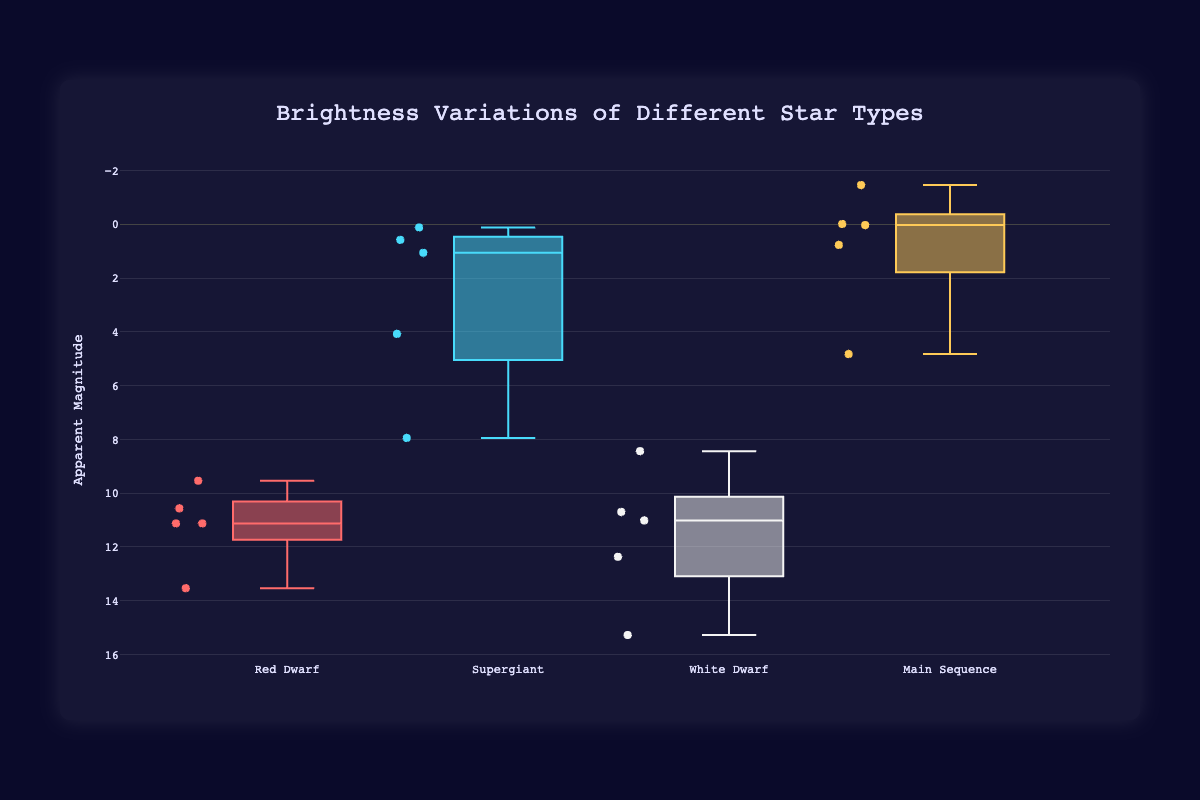What is the title of the figure? The title of the figure is mentioned at the top of the plot.
Answer: Brightness Variations of Different Star Types How many star types are shown in the figure? Count the different categories on the x-axis.
Answer: Four (Red Dwarf, Supergiant, White Dwarf, Main Sequence) Which star type has the highest median brightness? The median is represented by the line within the box. Identify the star type with the line closest to the top of the y-axis.
Answer: Main Sequence What is the approximate range of magnitudes for the White Dwarf category? Observe the top and bottom of the box plot for the White Dwarf category.
Answer: Approximately from 8.44 to 15.28 Which star in the Supergiant category has the highest magnitude? Look at the individual points on the Supergiant box plot and identify the highest value.
Answer: VY Canis Majoris Which category has a smaller interquartile range, Red Dwarf or Main Sequence? The interquartile range is the box's length. Compare the boxes of Red Dwarf and Main Sequence.
Answer: Main Sequence What is the median magnitude of the Red Dwarf category? The median is the line inside the box. Check the position of the line in the Red Dwarf box plot.
Answer: 11.13 How does the variation in brightness compare between Red Dwarf and Supergiant stars? Compare the spread of data points (range, interquartile range) in the box plots of Red Dwarf and Supergiant categories.
Answer: Supergiants show a much wider variation in brightness than Red Dwarfs List the stars in the Main Sequence category with a negative magnitude. Look for points in the Main Sequence box plot below the zero line on the y-axis.
Answer: Alpha Centauri A, Sirius A Which category has the star with the lowest magnitude and what is the star's name? Identify the category and then find the individual point with the lowest magnitude in that category.
Answer: Main Sequence, Sirius A 